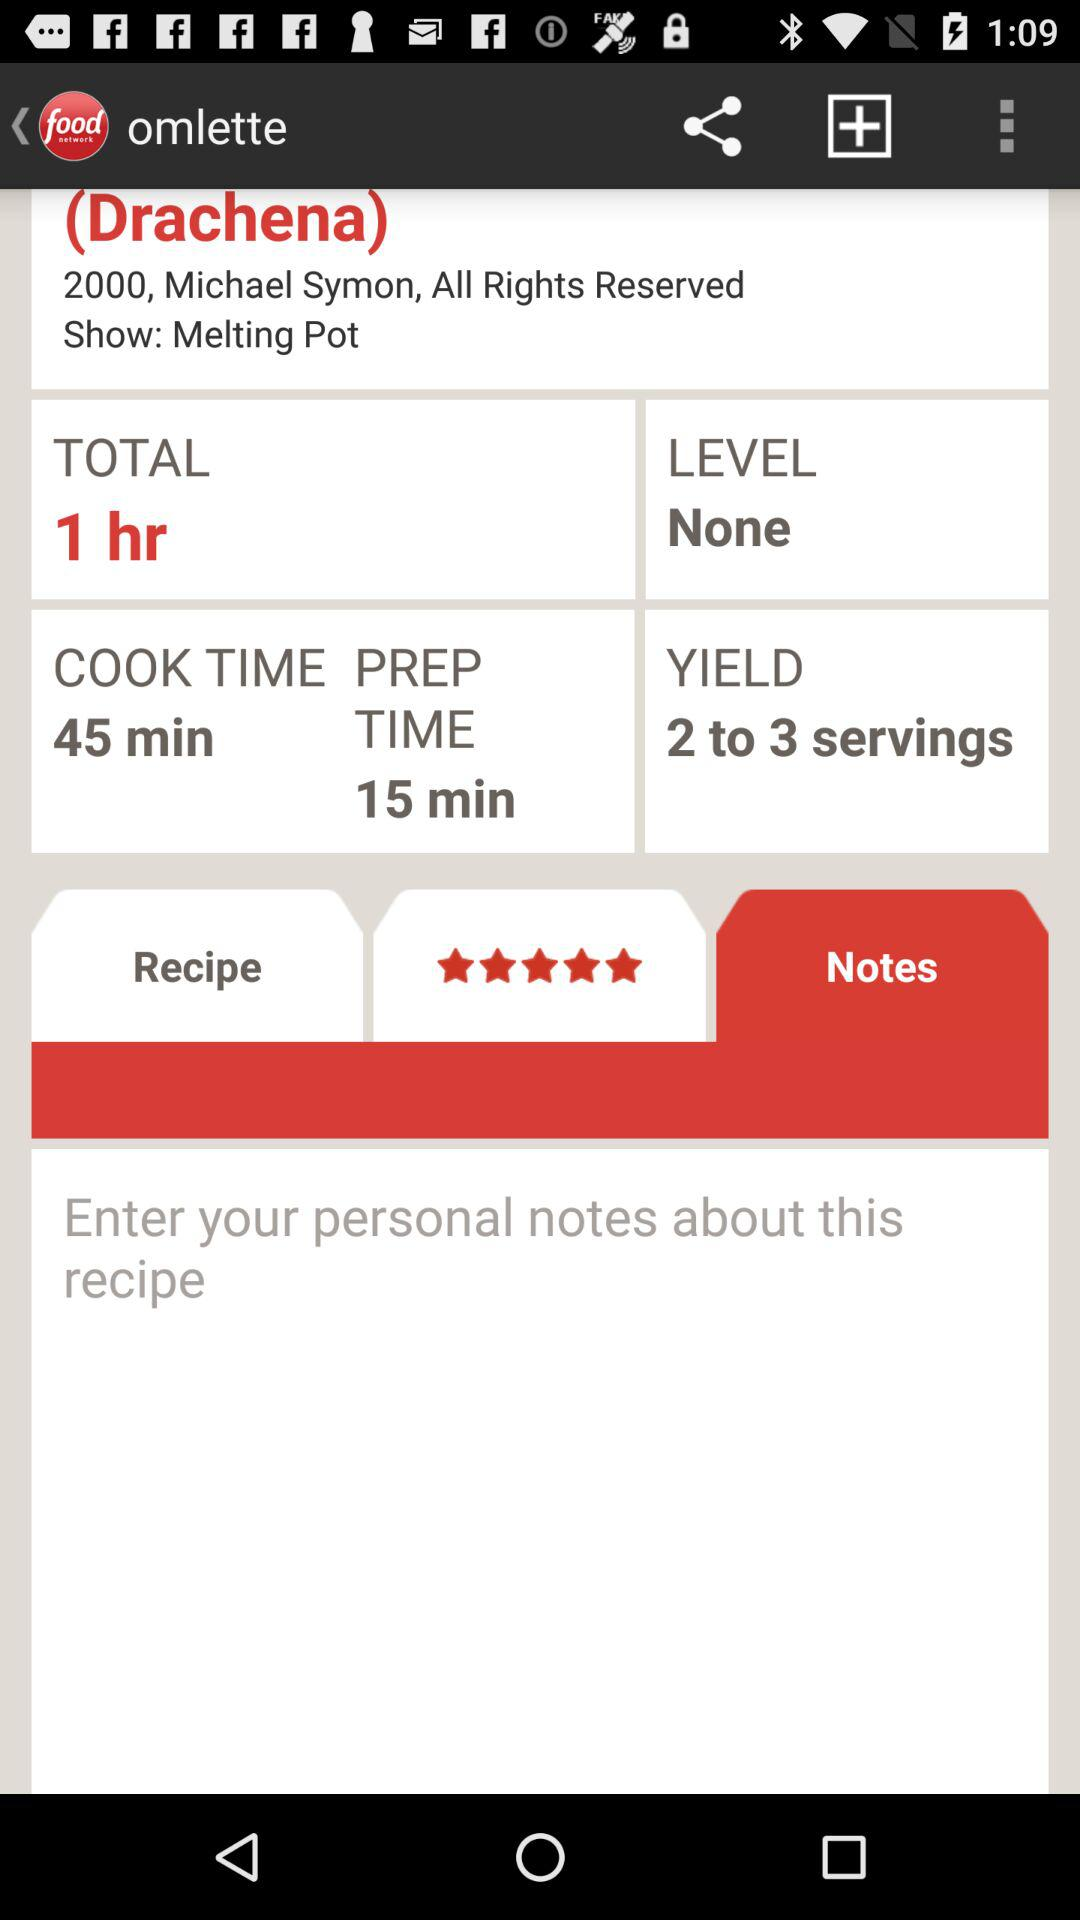What is the cook time duration? The cook time duration is 45 minutes. 